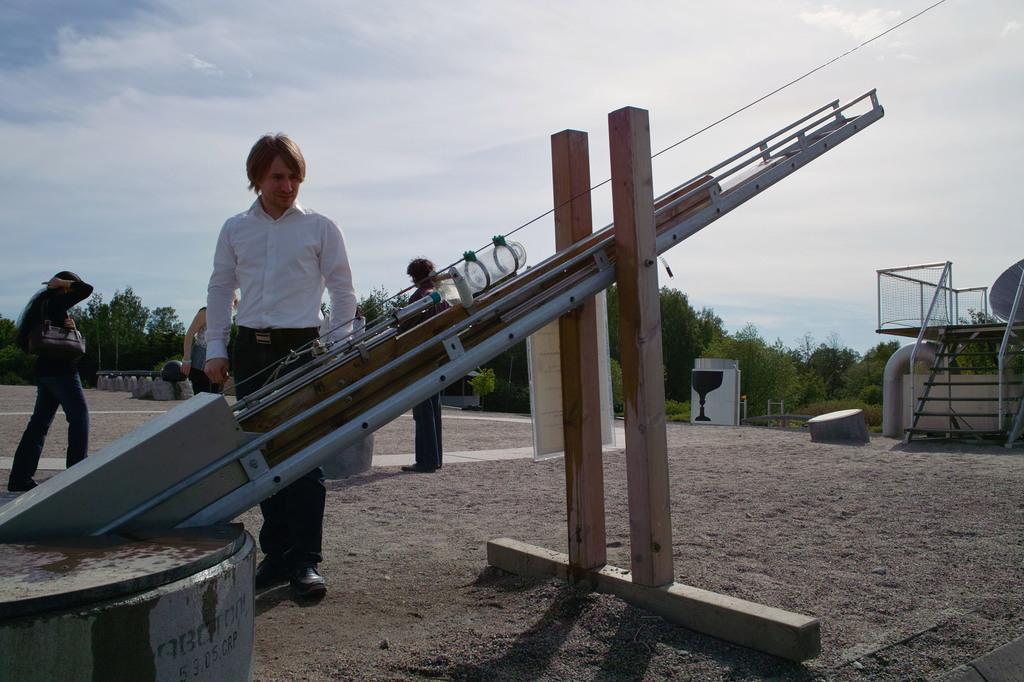In one or two sentences, can you explain what this image depicts? In this image I can see a person standing in front of the pole and I can see there are some other persons standing on the ground , in the background I can see the sky and tree and staircase 